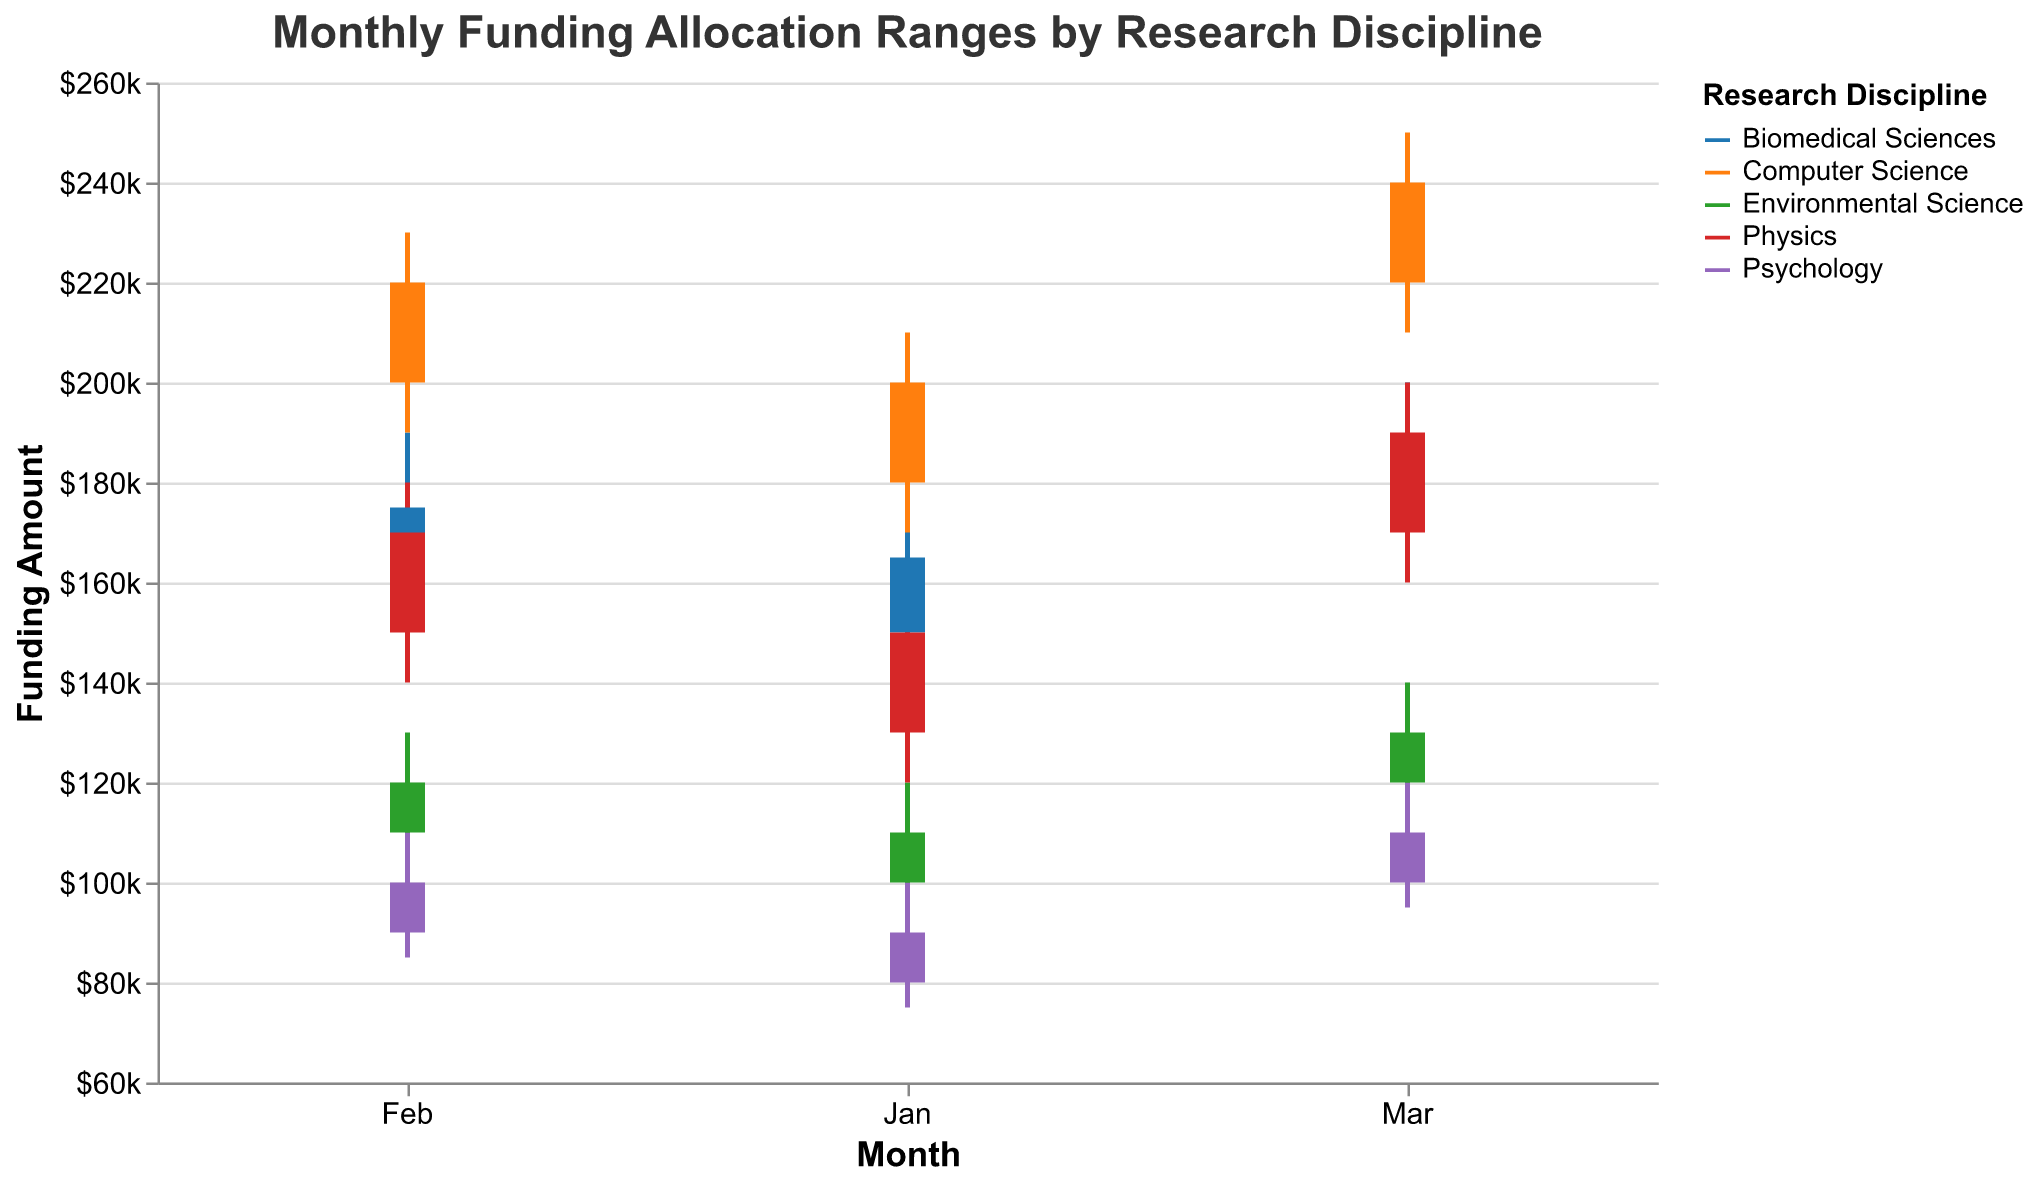What is the title of the figure? The title of the figure is located at the top and can be read directly.
Answer: Monthly Funding Allocation Ranges by Research Discipline Which research discipline has the highest funding allocation in March? From March data, observe the "High" values; Computer Science has the highest at 250,000.
Answer: Computer Science What is the color used to represent Biomedical Sciences? From the legend, Biomedical Sciences is represented using a specific color; in this case, it is blue.
Answer: Blue What is the range of funding allocations for Environmental Science in January? The range is calculated as High - Low for January: 120,000 - 90,000 = 30,000.
Answer: 30,000 Which discipline had the widest funding range in any month? Look for the highest difference between High and Low across all disciplines and months; Computer Science in March has 250,000 - 210,000 = 40,000.
Answer: Computer Science in March What was the closing funding allocation for Physics in February? Locate the value under the "Close" column for Physics in February; it is 170,000.
Answer: 170,000 Between January and March, in which month did Psychology receive its highest closing funding allocation? Compare the "Close" values for each month: Jan (90,000), Feb (100,000), Mar (110,000). March has the highest closing value.
Answer: March What is the average opening funding allocation for Computer Science over the three months? Sum the "Open" values for Jan, Feb, and Mar (180,000 + 200,000 + 220,000) and divide by 3: (600,000 / 3) = 200,000.
Answer: 200,000 How much did the funding allocation for Biomedical Sciences increase from January to March? Calculate the difference in "Close" values between Jan and Mar: 185,000 - 165,000 = 20,000.
Answer: 20,000 For Environmental Science, in which month was the difference between the opening and closing funding allocation the smallest? Calculate the differences for each month: Jan (110,000 - 100,000 = 10,000), Feb (120,000 - 110,000 = 10,000), Mar (130,000 - 120,000 = 10,000). All months have a 10,000 difference.
Answer: All months are equal 